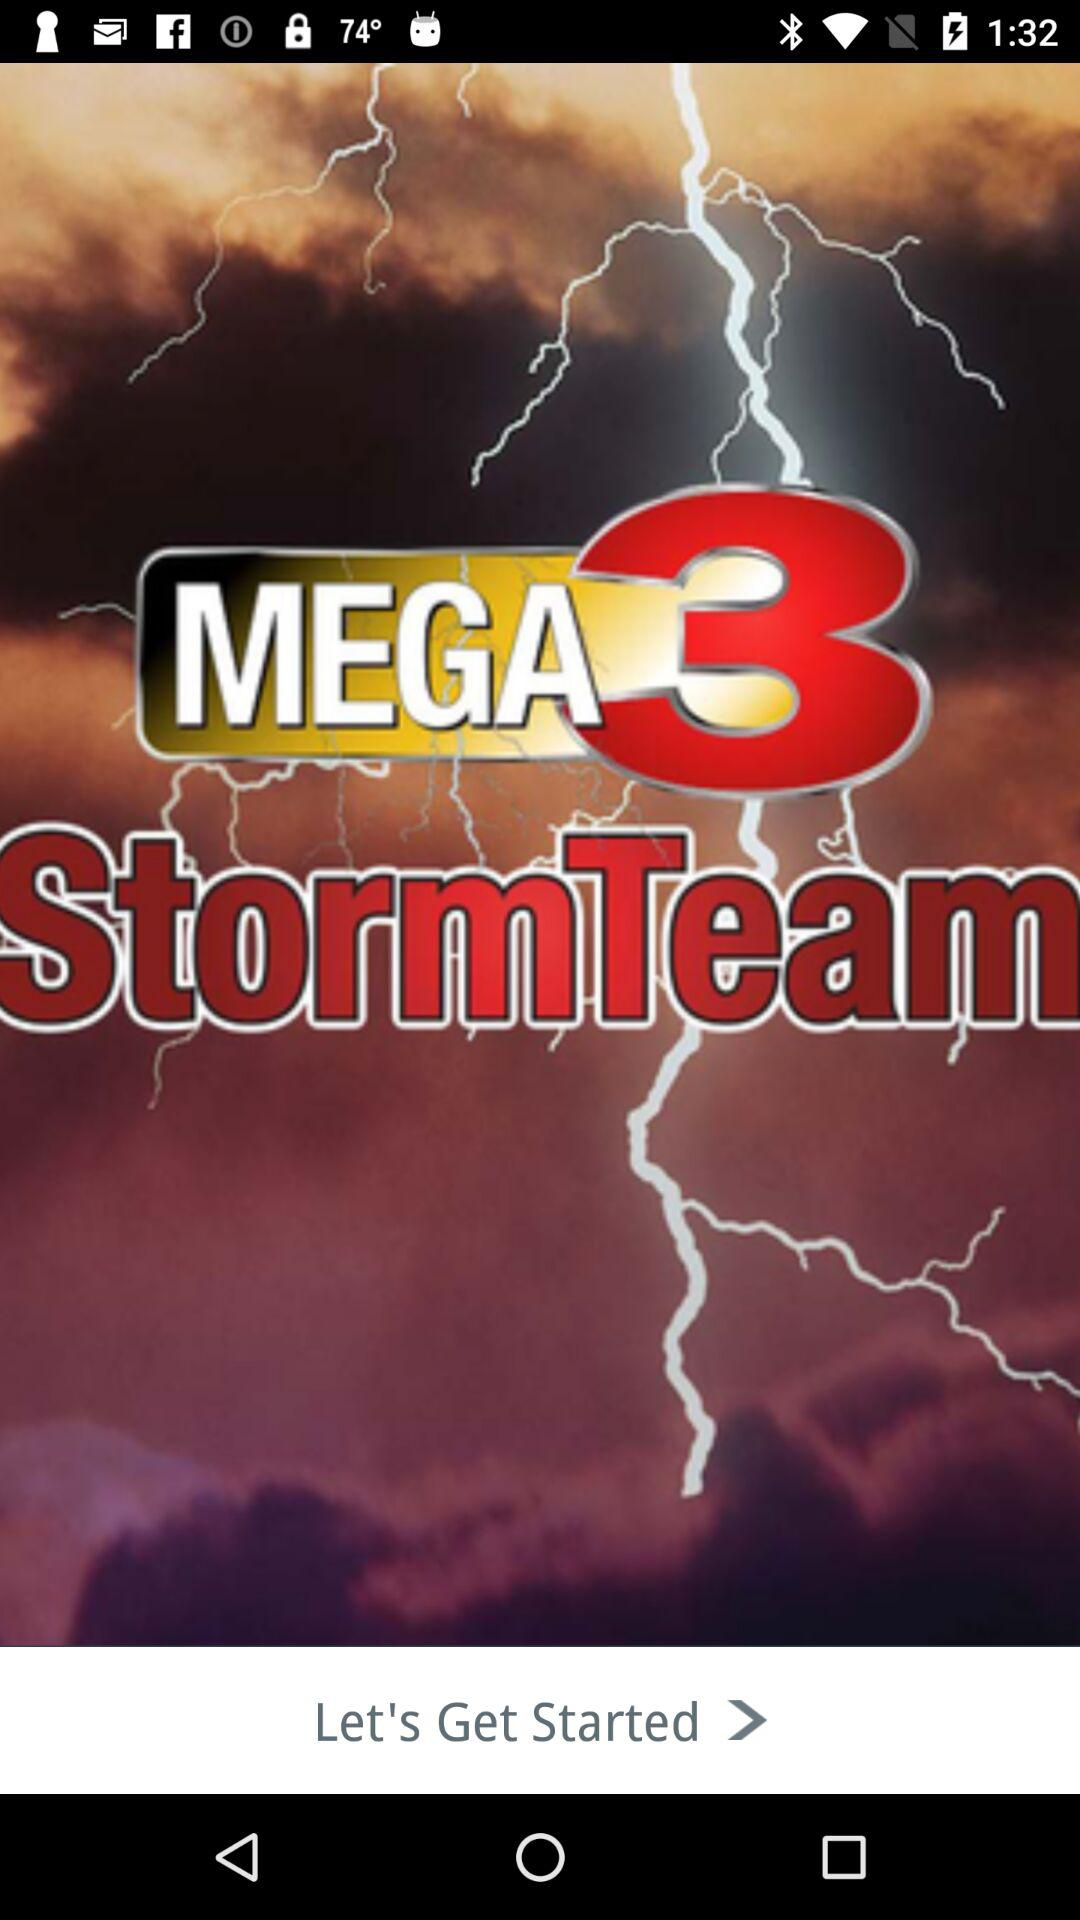What is the application name? The application name is "MEGA3 StormTeam". 